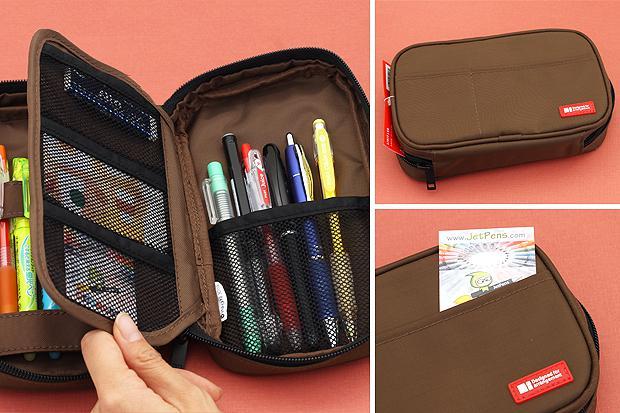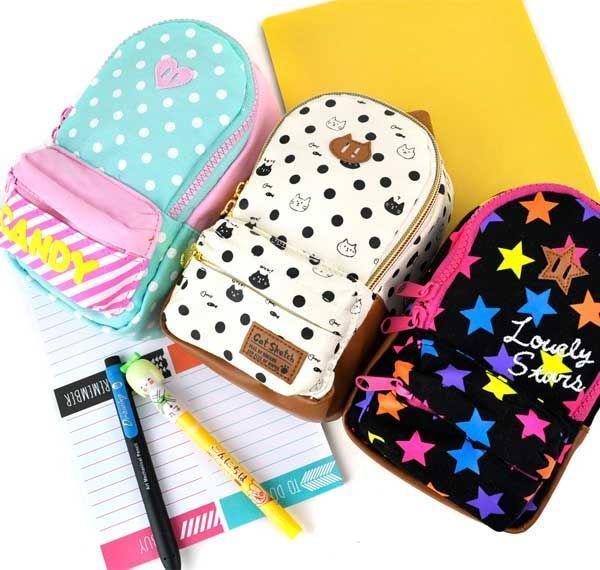The first image is the image on the left, the second image is the image on the right. For the images shown, is this caption "There is a human hand touching a pencil case in one of the images." true? Answer yes or no. Yes. The first image is the image on the left, the second image is the image on the right. Given the left and right images, does the statement "The left-hand image shows a double-zipper topped pencil case featuring sky-blue color." hold true? Answer yes or no. No. 